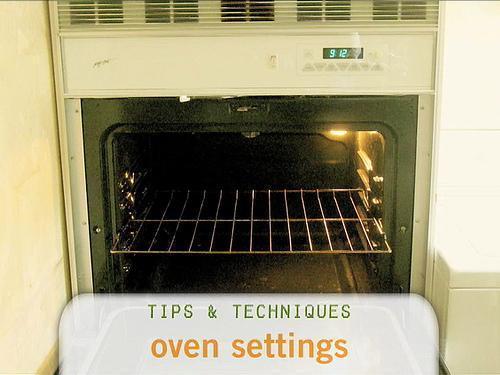How many ovens are there?
Give a very brief answer. 1. 